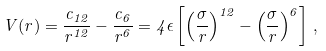<formula> <loc_0><loc_0><loc_500><loc_500>V ( r ) = \frac { c _ { 1 2 } } { r ^ { 1 2 } } - \frac { c _ { 6 } } { r ^ { 6 } } = 4 \epsilon \left [ \left ( \frac { \sigma } { r } \right ) ^ { 1 2 } - \left ( \frac { \sigma } { r } \right ) ^ { 6 } \right ] \, ,</formula> 